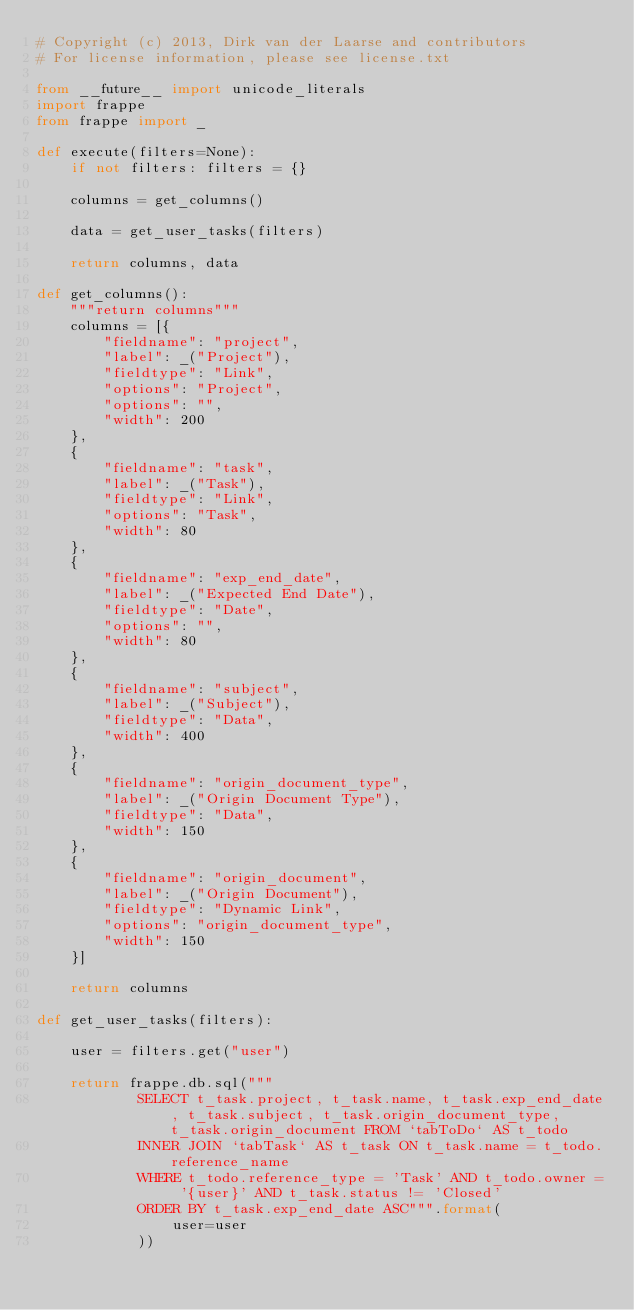Convert code to text. <code><loc_0><loc_0><loc_500><loc_500><_Python_># Copyright (c) 2013, Dirk van der Laarse and contributors
# For license information, please see license.txt

from __future__ import unicode_literals
import frappe
from frappe import _

def execute(filters=None):
	if not filters: filters = {}

	columns = get_columns()

	data = get_user_tasks(filters)

	return columns, data

def get_columns():
	"""return columns"""
	columns = [{
	    "fieldname": "project",
	    "label": _("Project"),
	    "fieldtype": "Link",
	    "options": "Project",
	    "options": "",
	    "width": 200
	},
	{
	    "fieldname": "task",
	    "label": _("Task"),
	    "fieldtype": "Link",
	    "options": "Task",
	    "width": 80
	},
	{
	    "fieldname": "exp_end_date",
	    "label": _("Expected End Date"),
	    "fieldtype": "Date",
	    "options": "",
	    "width": 80
	},
	{
	    "fieldname": "subject",
	    "label": _("Subject"),
	    "fieldtype": "Data",
	    "width": 400
	},
	{
	    "fieldname": "origin_document_type",
	    "label": _("Origin Document Type"),
	    "fieldtype": "Data",
	    "width": 150
	},
	{
	    "fieldname": "origin_document",
	    "label": _("Origin Document"),
	    "fieldtype": "Dynamic Link",
		"options": "origin_document_type",
	    "width": 150
	}]

	return columns

def get_user_tasks(filters):

	user = filters.get("user")

	return frappe.db.sql("""
			SELECT t_task.project, t_task.name, t_task.exp_end_date, t_task.subject, t_task.origin_document_type, t_task.origin_document FROM `tabToDo` AS t_todo
            INNER JOIN `tabTask` AS t_task ON t_task.name = t_todo.reference_name
            WHERE t_todo.reference_type = 'Task' AND t_todo.owner = '{user}' AND t_task.status != 'Closed'
            ORDER BY t_task.exp_end_date ASC""".format(
				user=user
			))
</code> 